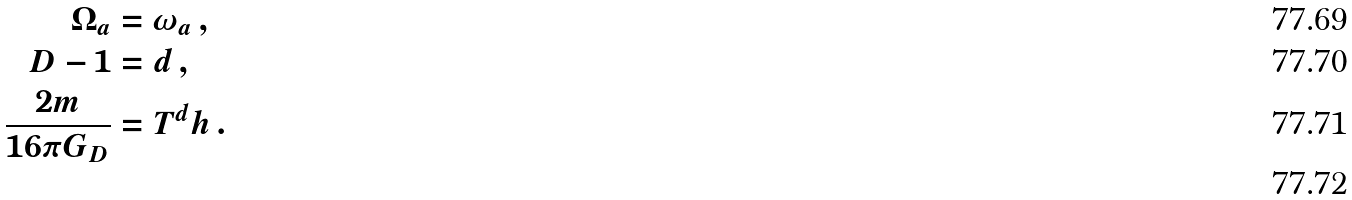Convert formula to latex. <formula><loc_0><loc_0><loc_500><loc_500>\Omega _ { a } & = \omega _ { a } \, , \\ D - 1 & = d \, , \\ \frac { 2 m } { 1 6 \pi G _ { D } } & = T ^ { d } h \, . \\</formula> 